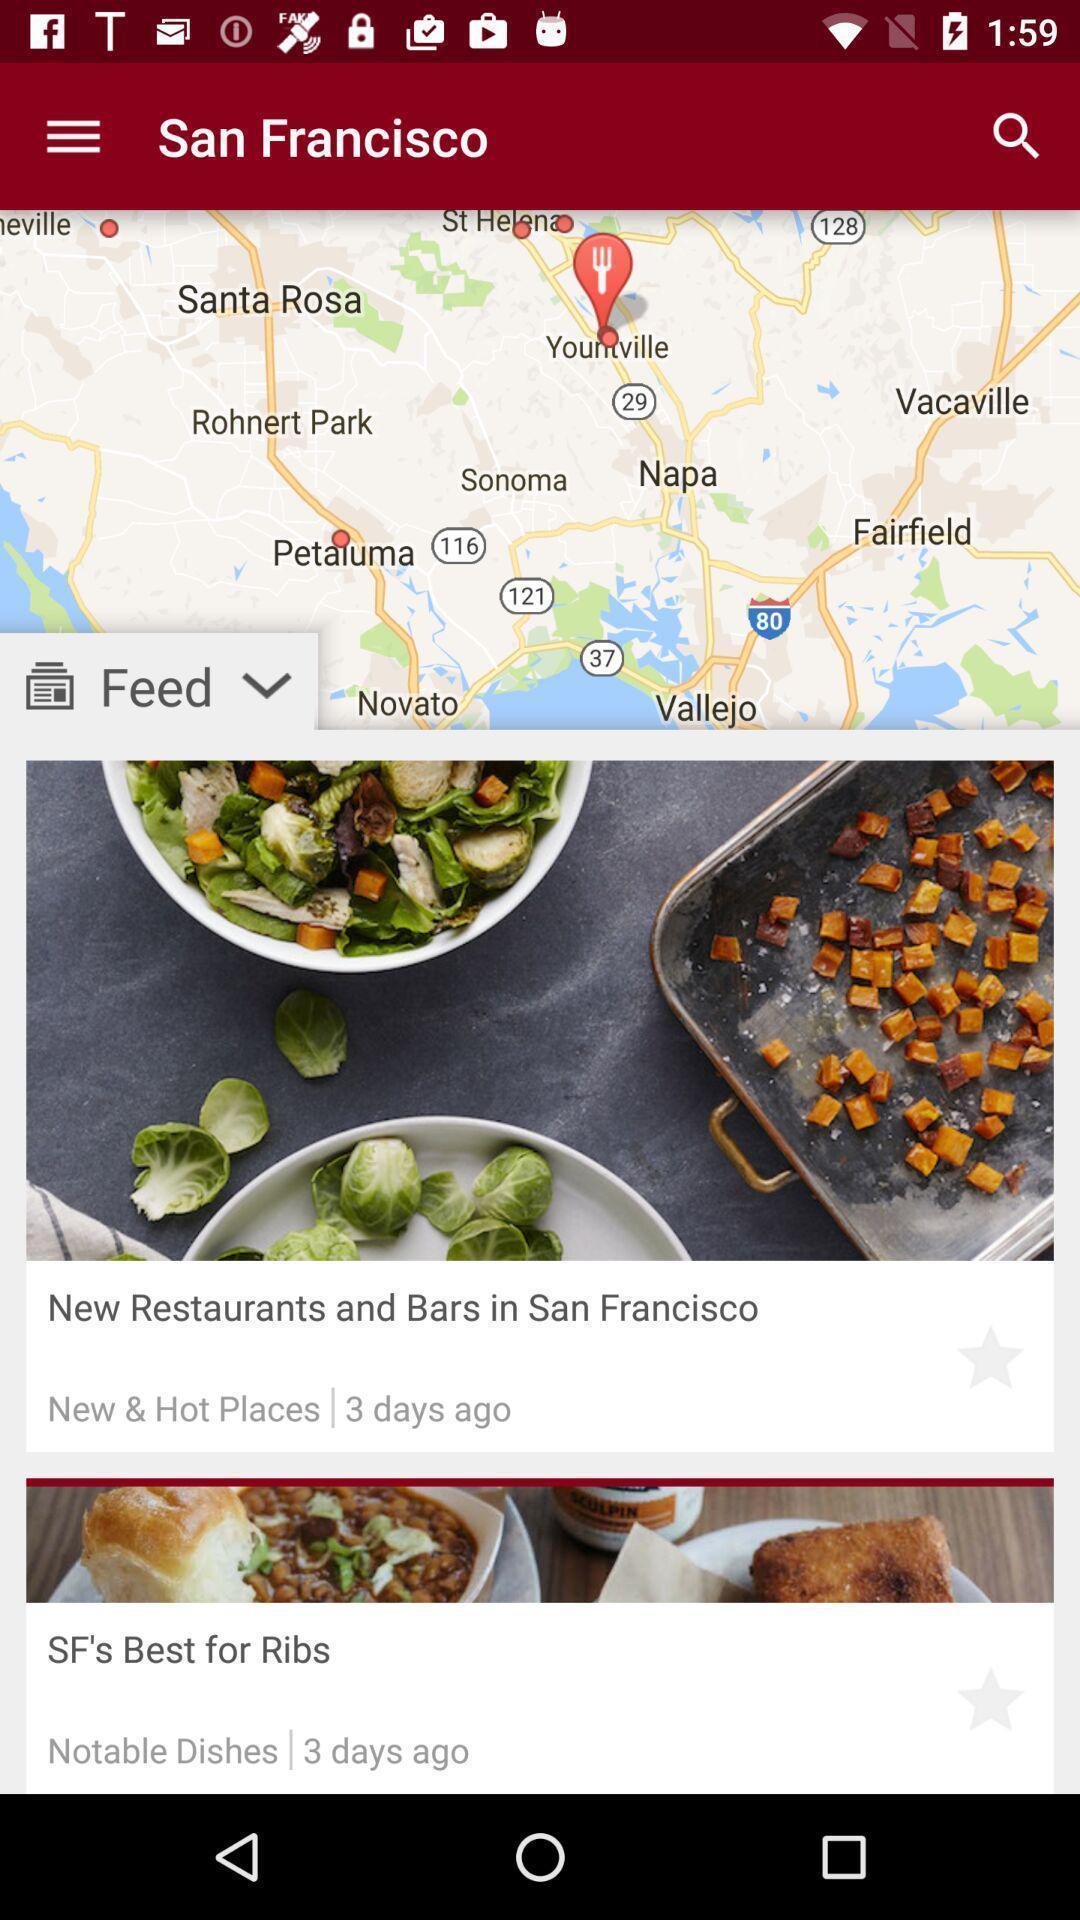Explain what's happening in this screen capture. Page displaying with restaurants and bar locations. 